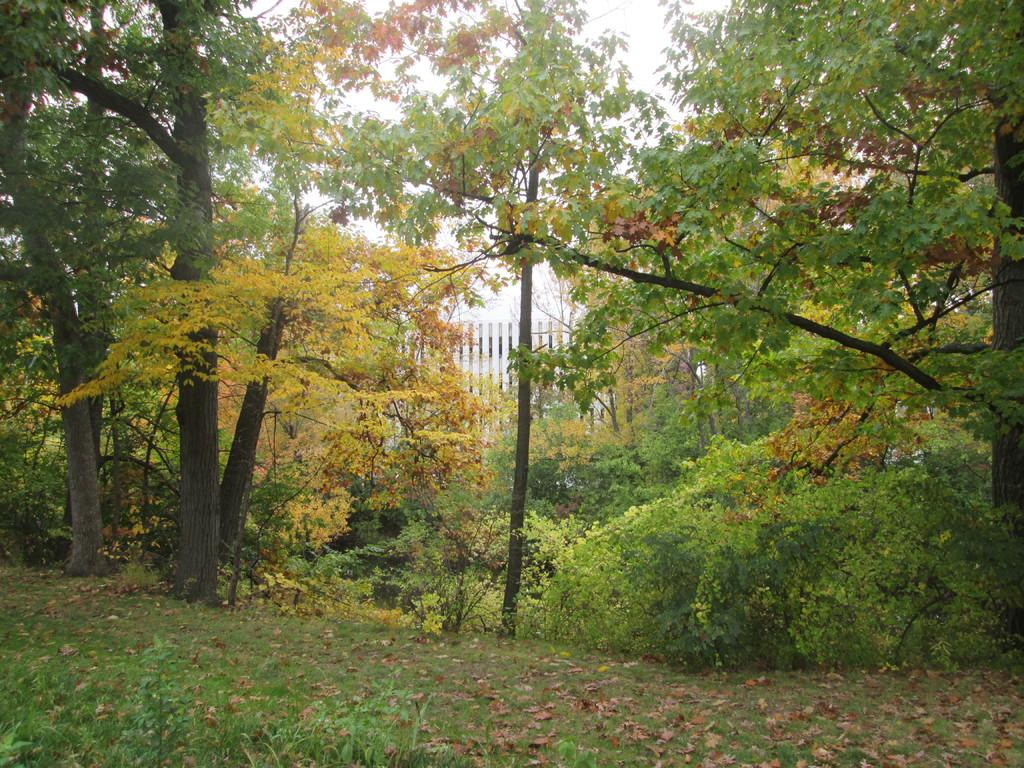What type of surface is visible in the image? There is a grass surface with plants in the image. What type of vegetation can be seen in the image? There are trees visible in the image. What architectural feature is present in the image? A part of the railing is present in the image. What part of the natural environment is visible in the image? A part of the sky is visible in the image. What type of wave can be seen crashing on the shore in the image? There is no shore or wave present in the image; it features a grass surface with plants, trees, a railing, and a part of the sky. 